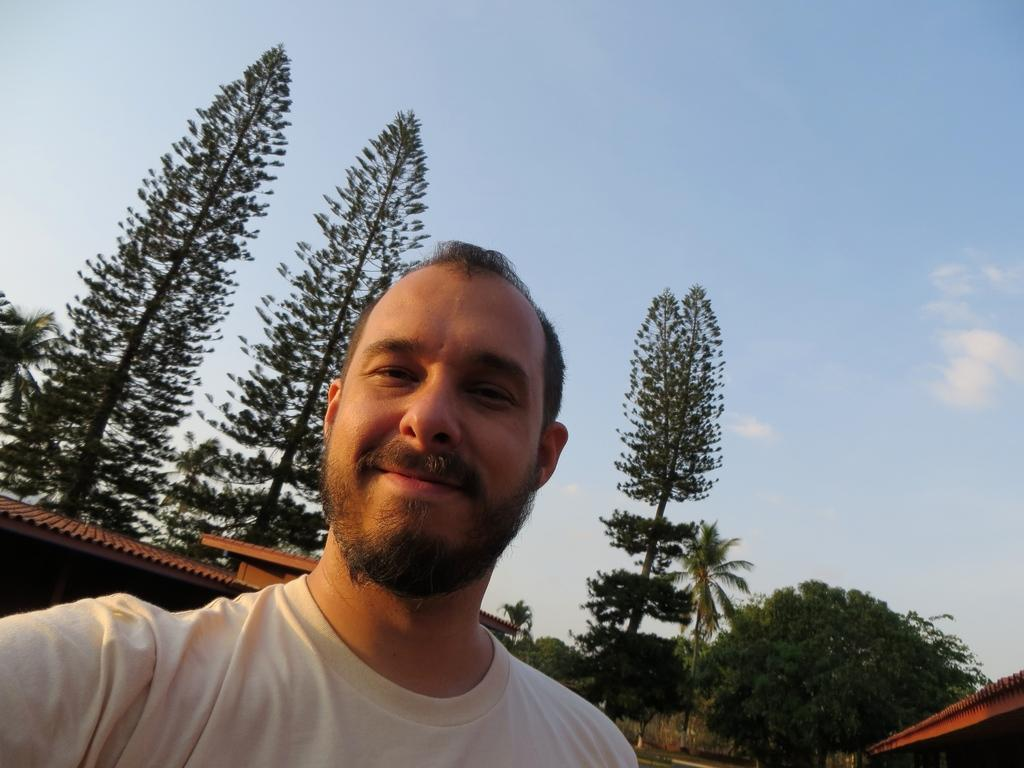Who is the main subject in the image? There is a man in the image. What is the man doing in the image? The man is taking a selfie. What can be seen in the background of the image? There are trees and houses behind the man, and the sky is visible at the top of the image. What type of flower is the man holding in the image? There is no flower present in the image; the man is taking a selfie with no visible objects in his hands. 